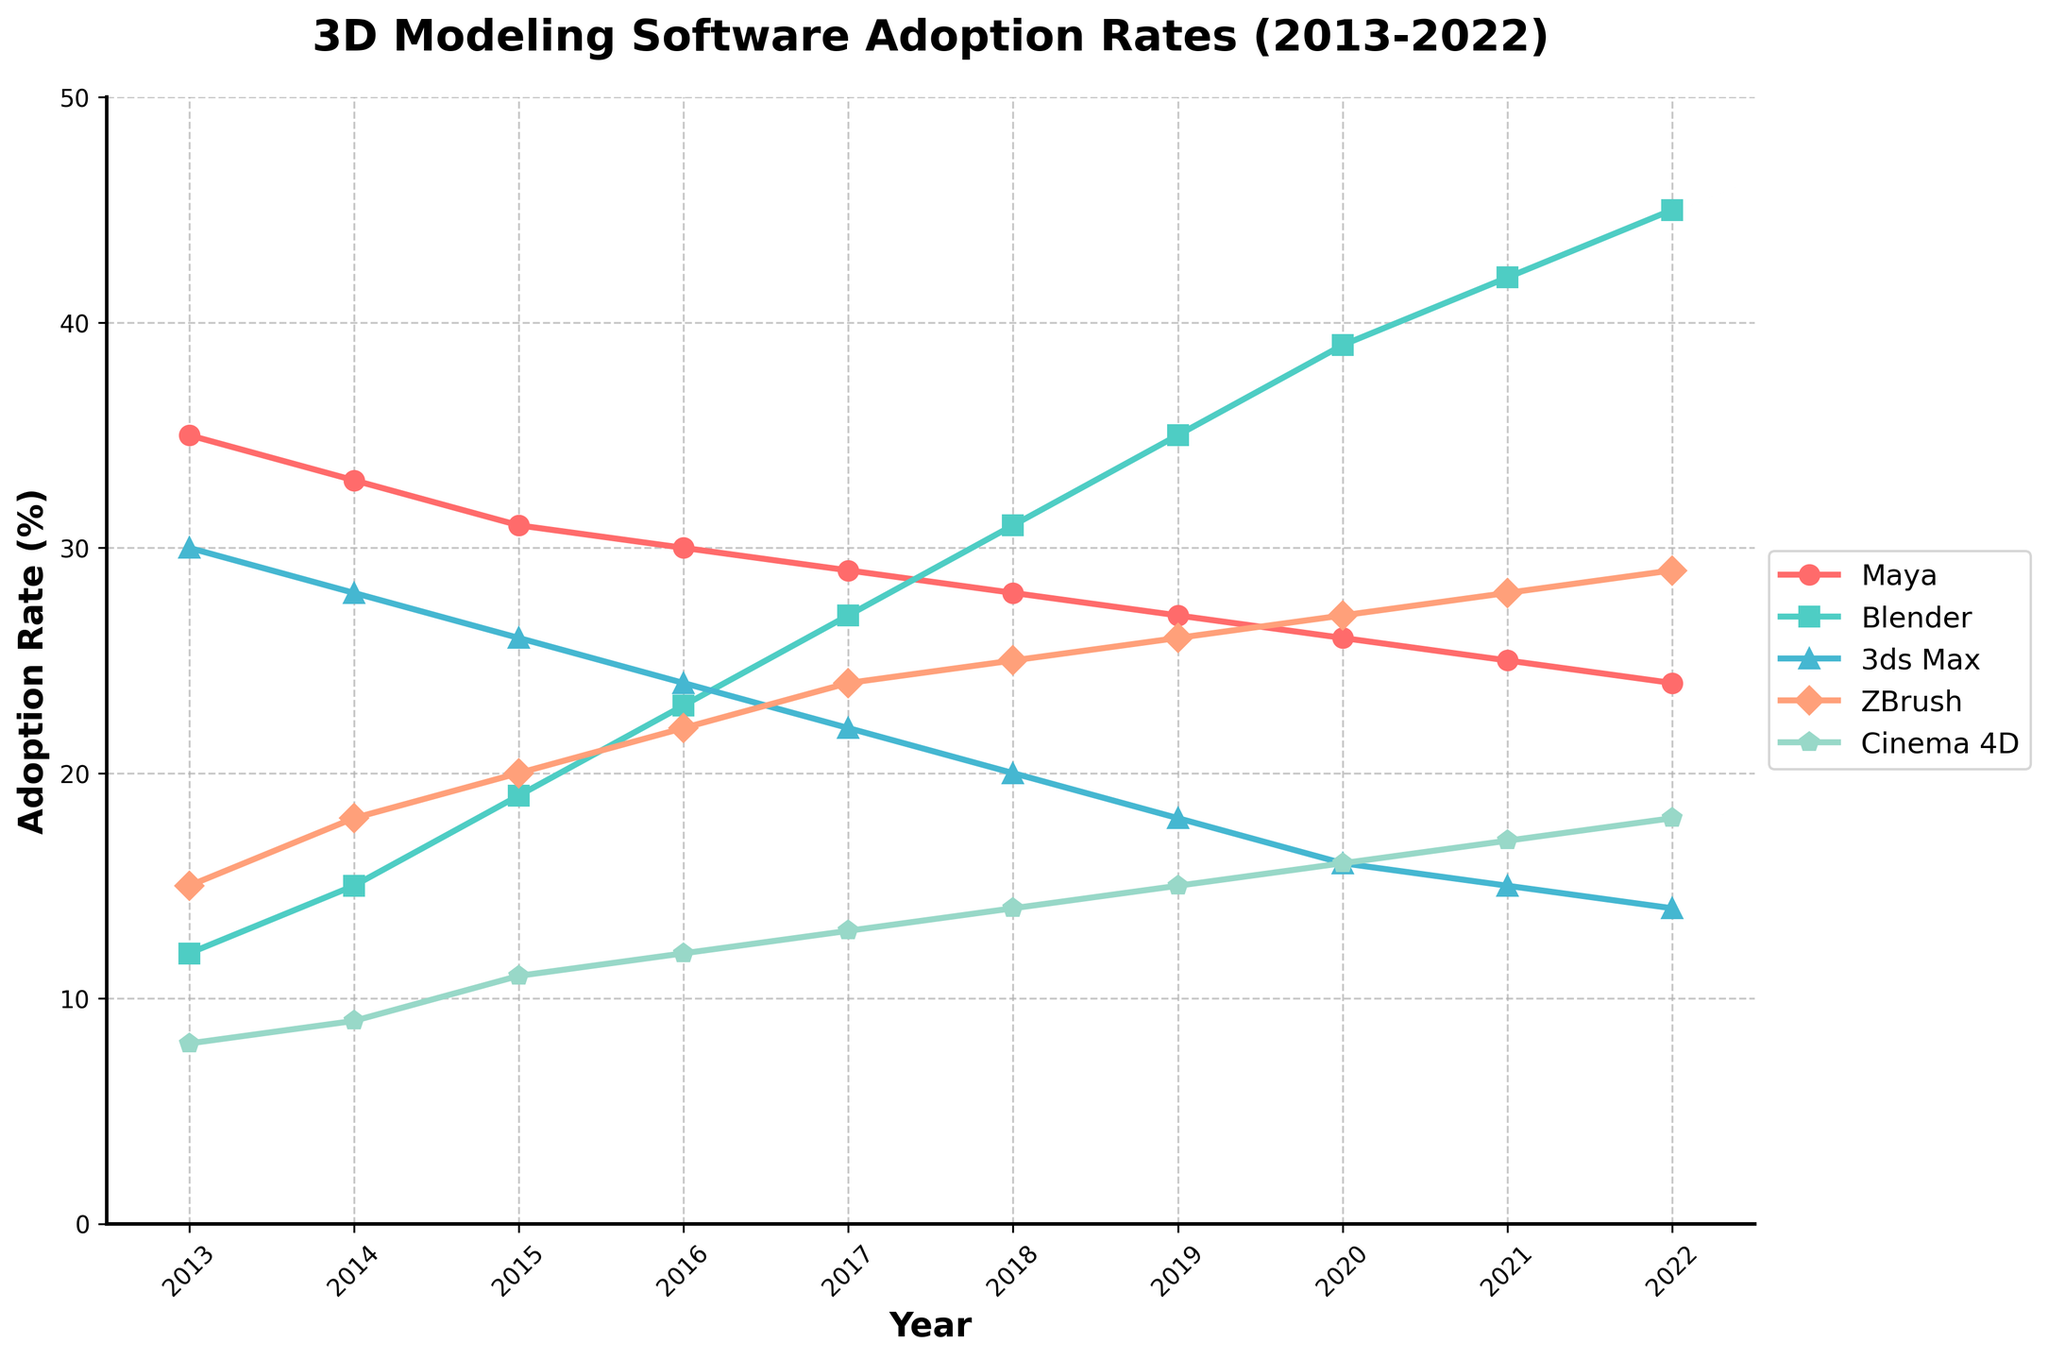What's the trend in the adoption rate of Blender from 2013 to 2022? To identify the trend in Blender's adoption rate, observe Blender's line from 2013 to 2022. The line clearly shows an upward slope, indicating an increasing adoption rate over the years.
Answer: Increasing In which year did Cinema 4D have the highest adoption rate? To find the highest adoption rate of Cinema 4D, look for the peak point on Cinema 4D's line (orange with diamond markers). The highest point is around 18% in 2022.
Answer: 2022 Which software had the most significant decline in adoption rate from 2013 to 2022? Compare the adoption rate changes of all software between 2013 and 2022. Maya shows a decrease from 35% to 24%, which is the most significant decline.
Answer: Maya Which year saw the highest overall adoption rates among all software combined? Calculate the combined adoption rates for each year and compare them. The year with the highest total when summing all rates is 2022 (24 + 45 + 14 + 29 + 18 = 130).
Answer: 2022 How does the adoption rate of ZBrush in 2018 compare to that in 2022? Compare the values of ZBrush in 2018 and 2022. In 2018, ZBrush is at 25%, while in 2022, it is at 29%. ZBrush has increased by 4 percentage points.
Answer: Increased by 4 points Which software had the most consistent adoption rate trend over the decade? To determine consistency, look at the smoothness and lack of significant fluctuations in the lines. Maya's adoption rate shows a relatively smooth decline, indicating consistency.
Answer: Maya What was the average adoption rate of 3ds Max over the decade? Calculate the mean of 3ds Max's values from 2013 to 2022: (30+28+26+24+22+20+18+16+15+14)/10 = 21.3%
Answer: 21.3% Did any software have an adoption rate equal to Blender's highest point at any time? Blender reaches its peak at 45% in 2022. Check if any other software hits 45% or more. None of the other software reaches this rate.
Answer: No Compare Cinema 4D's adoption rate in 2013 to Blender's in 2013. Which was higher and by how much? In 2013, Cinema 4D's rate was 8%, and Blender's was 12%. Blender's rate is higher by 4 percentage points.
Answer: Blender by 4 points What's the difference in the adoption rates of ZBrush and 3ds Max in 2020? In 2020, ZBrush is at 27% and 3ds Max is at 16%. The difference is 27% - 16% = 11 percentage points.
Answer: 11 points 